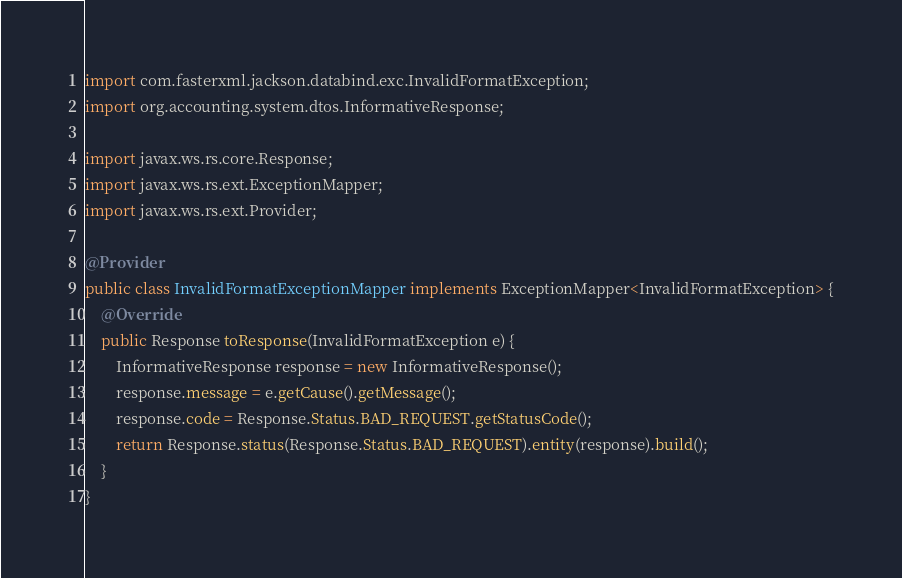<code> <loc_0><loc_0><loc_500><loc_500><_Java_>import com.fasterxml.jackson.databind.exc.InvalidFormatException;
import org.accounting.system.dtos.InformativeResponse;

import javax.ws.rs.core.Response;
import javax.ws.rs.ext.ExceptionMapper;
import javax.ws.rs.ext.Provider;

@Provider
public class InvalidFormatExceptionMapper implements ExceptionMapper<InvalidFormatException> {
    @Override
    public Response toResponse(InvalidFormatException e) {
        InformativeResponse response = new InformativeResponse();
        response.message = e.getCause().getMessage();
        response.code = Response.Status.BAD_REQUEST.getStatusCode();
        return Response.status(Response.Status.BAD_REQUEST).entity(response).build();
    }
}
</code> 